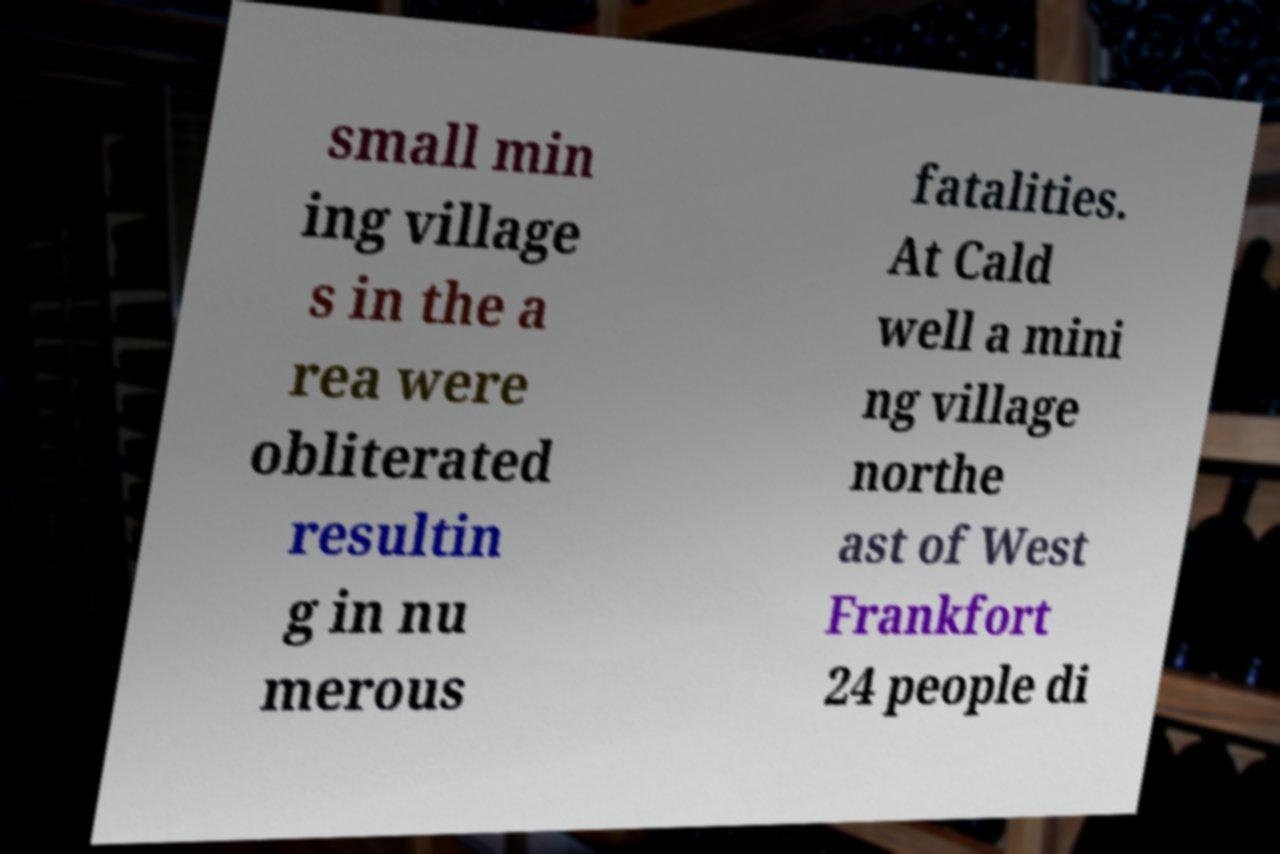There's text embedded in this image that I need extracted. Can you transcribe it verbatim? small min ing village s in the a rea were obliterated resultin g in nu merous fatalities. At Cald well a mini ng village northe ast of West Frankfort 24 people di 